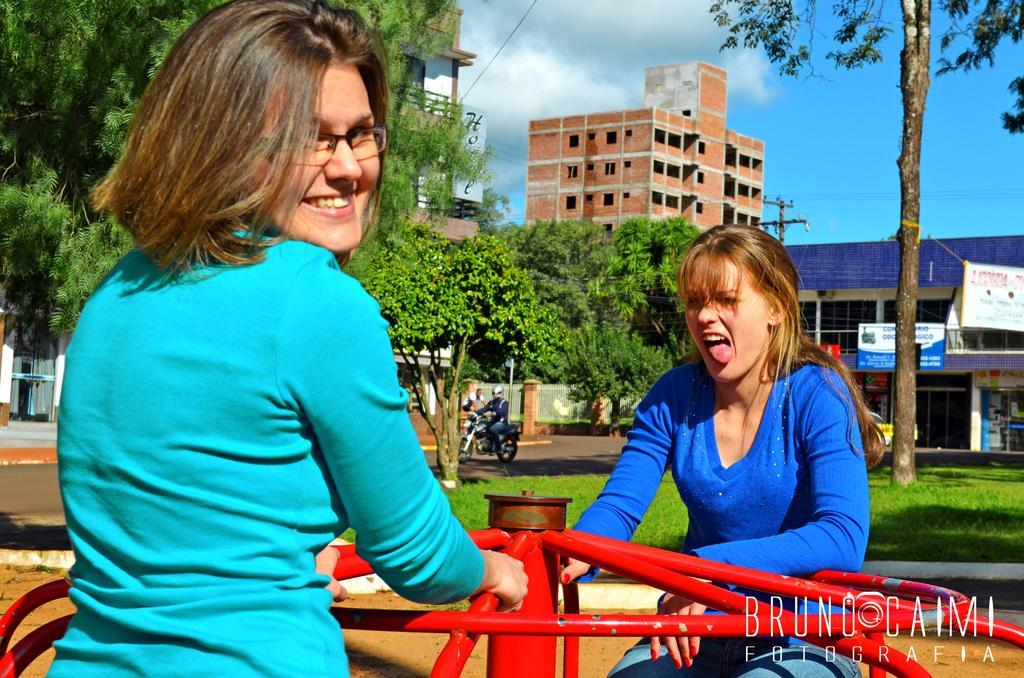Could you give a brief overview of what you see in this image? In this image we can see these people wearing blue dresses are sitting on the spinning ring. In the background, we can see grass, trees, vehicles moving on the road, brick buildings, boards and with clouds in the background. 